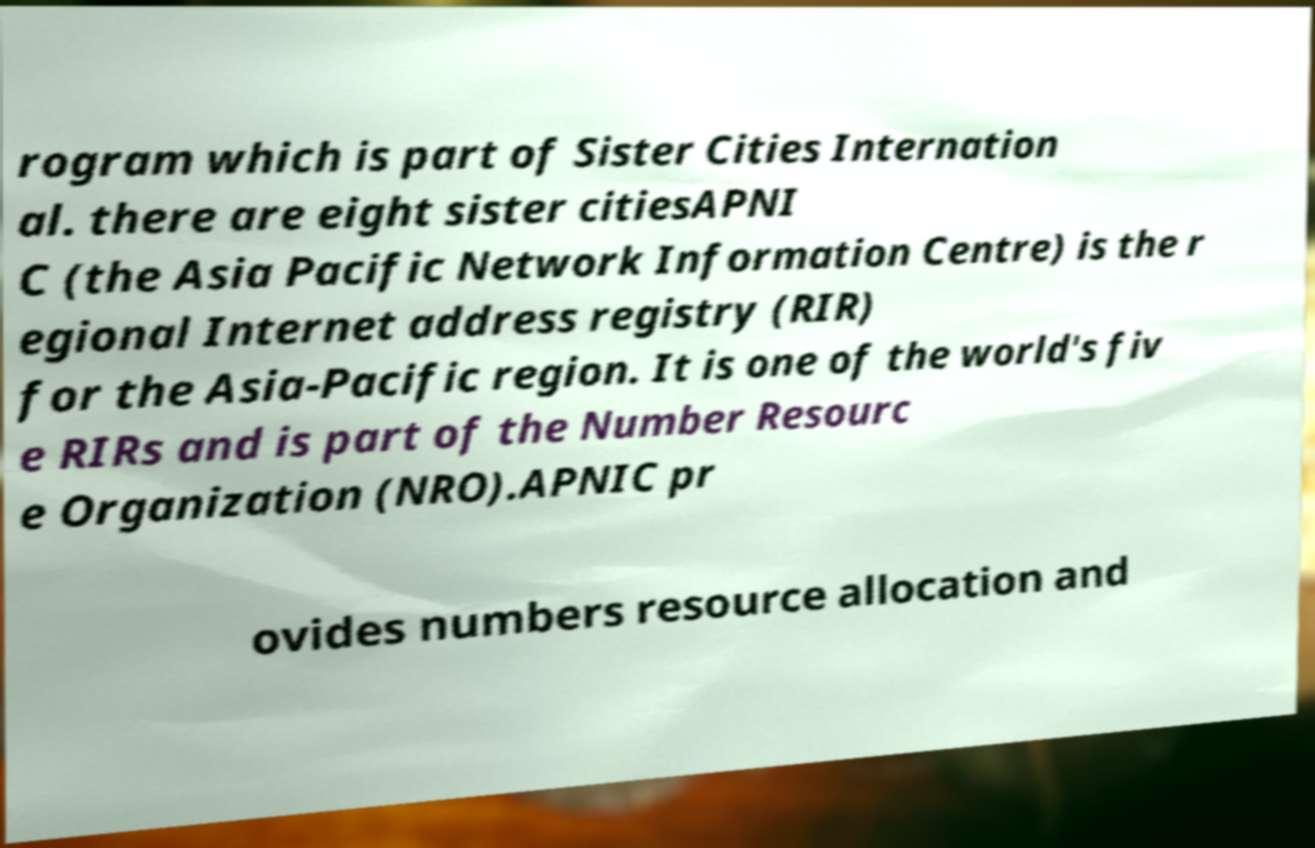Can you accurately transcribe the text from the provided image for me? rogram which is part of Sister Cities Internation al. there are eight sister citiesAPNI C (the Asia Pacific Network Information Centre) is the r egional Internet address registry (RIR) for the Asia-Pacific region. It is one of the world's fiv e RIRs and is part of the Number Resourc e Organization (NRO).APNIC pr ovides numbers resource allocation and 